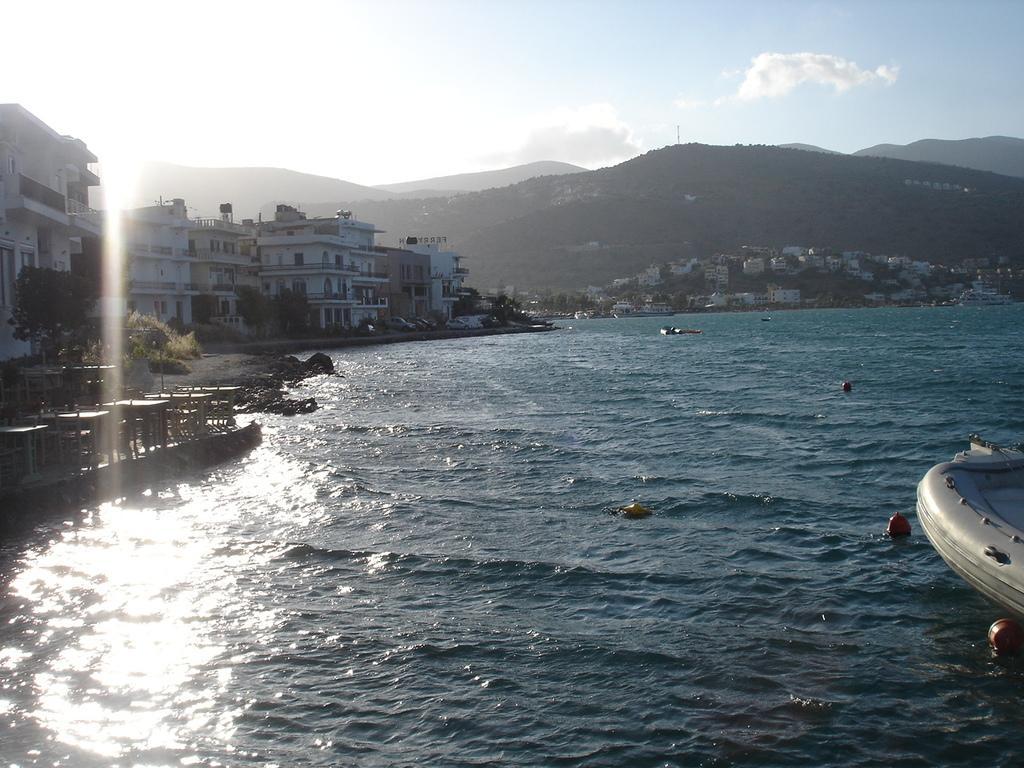In one or two sentences, can you explain what this image depicts? There is water. On the right side we can see a part of a boat. On the left side there are buildings, trees. In the background there are hills, buildings and sky with clouds. 